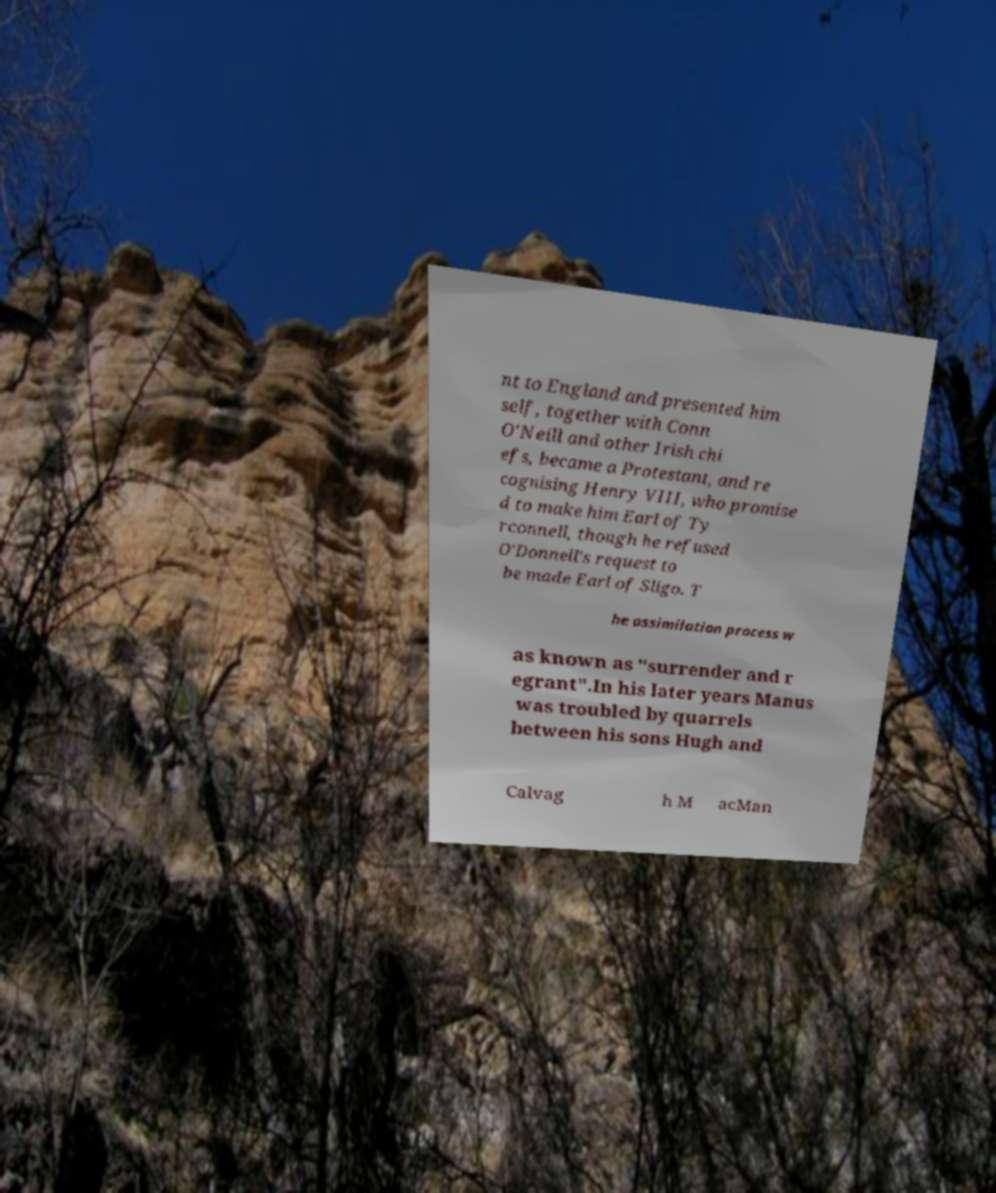Please read and relay the text visible in this image. What does it say? nt to England and presented him self, together with Conn O'Neill and other Irish chi efs, became a Protestant, and re cognising Henry VIII, who promise d to make him Earl of Ty rconnell, though he refused O'Donnell's request to be made Earl of Sligo. T he assimilation process w as known as "surrender and r egrant".In his later years Manus was troubled by quarrels between his sons Hugh and Calvag h M acMan 